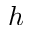<formula> <loc_0><loc_0><loc_500><loc_500>^ { h }</formula> 